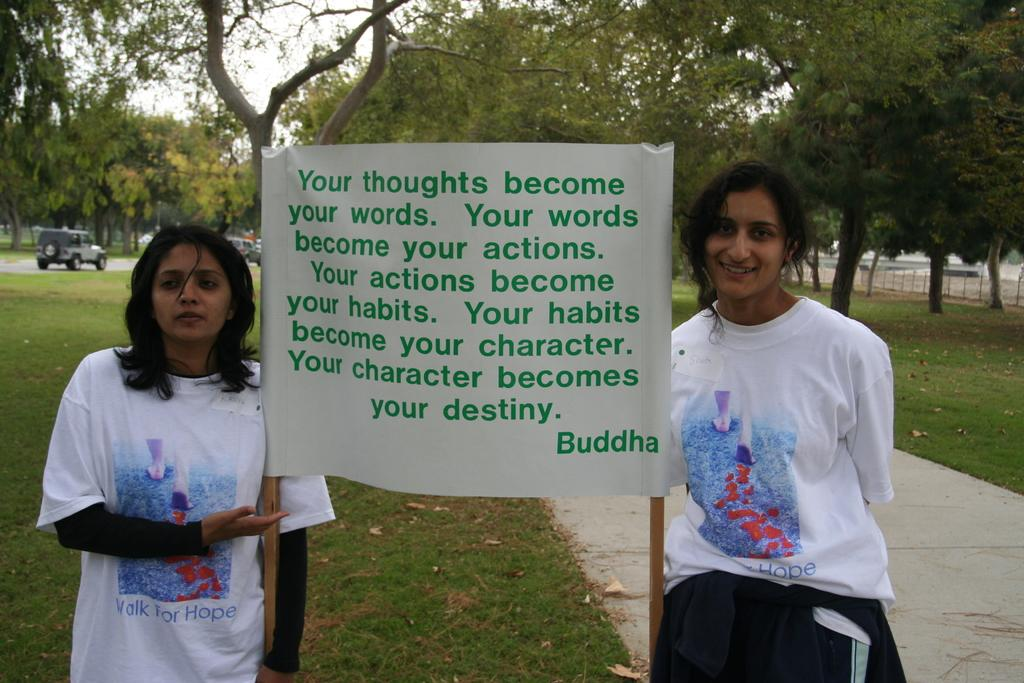<image>
Summarize the visual content of the image. Two girls hold a poster with a quote from Buddha on it. 